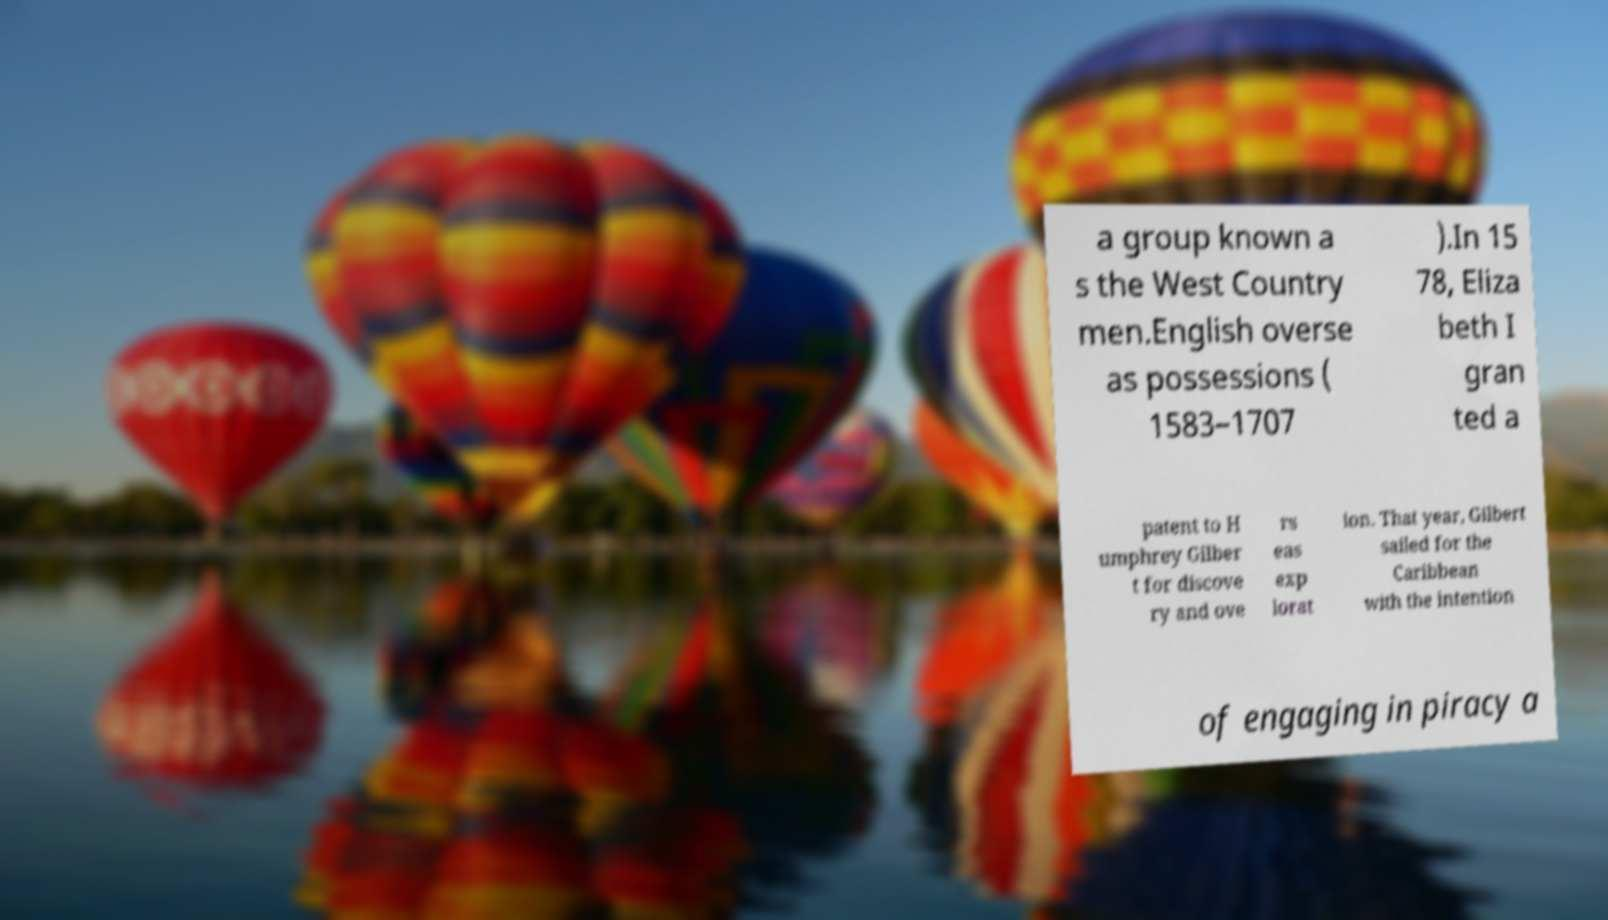Can you read and provide the text displayed in the image?This photo seems to have some interesting text. Can you extract and type it out for me? a group known a s the West Country men.English overse as possessions ( 1583–1707 ).In 15 78, Eliza beth I gran ted a patent to H umphrey Gilber t for discove ry and ove rs eas exp lorat ion. That year, Gilbert sailed for the Caribbean with the intention of engaging in piracy a 